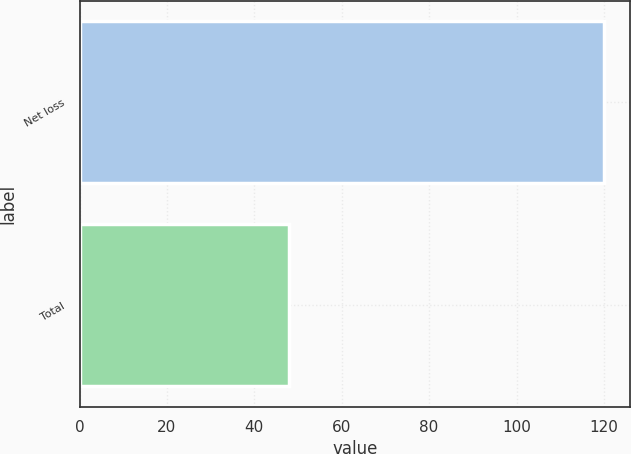<chart> <loc_0><loc_0><loc_500><loc_500><bar_chart><fcel>Net loss<fcel>Total<nl><fcel>120<fcel>48<nl></chart> 